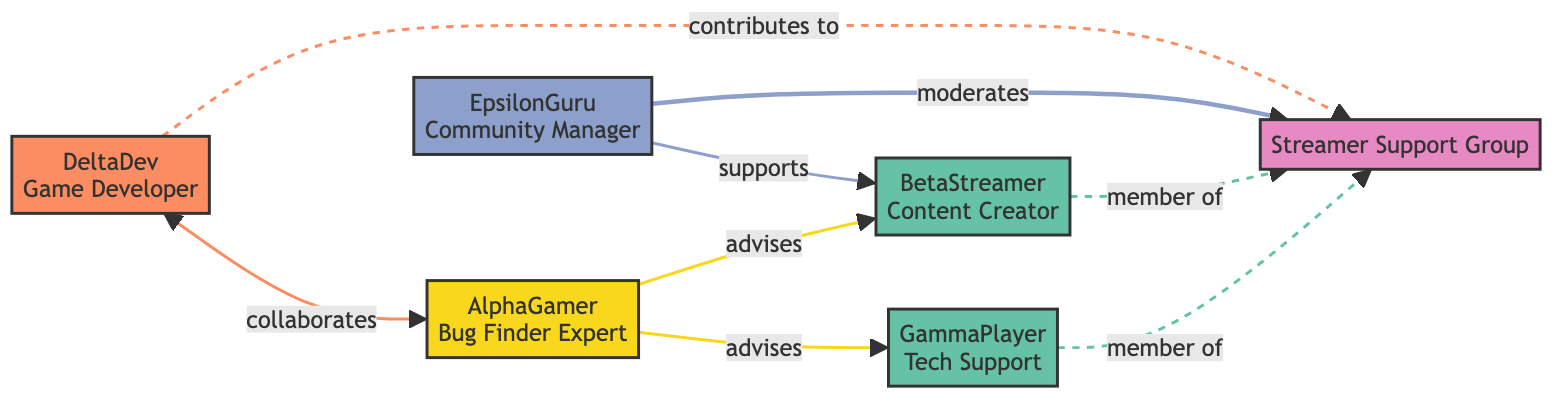What's the total number of nodes in the diagram? The diagram contains six distinct entities, which are represented as nodes. These nodes are alpha gamer, beta streamer, gamma player, delta dev, epsilon guru, and the support group. Thus, the total count is 6.
Answer: 6 Which streamer collaborates with DeltaDev? In the diagram, DeltaDev is shown to collaborate with AlphaGamer. The relationship is indicated by the connection labeled "collaborates." Thus, the answer is AlphaGamer.
Answer: AlphaGamer How many streamers are part of the support group? The diagram shows two members who are indicated to be part of the support group: BetaStreamer and GammaPlayer. Therefore, the count of streamers in the support group is 2.
Answer: 2 What type of relationship does EpsilonGuru have with BetaStreamer? The relationship between EpsilonGuru and BetaStreamer is labeled as "supports." This indicates that EpsilonGuru provides guidance and assistance to BetaStreamer. Hence, the answer is "supports."
Answer: supports Who moderates the Streamer Support Group? EpsilonGuru is explicitly mentioned in the diagram as the one who moderates the Streamer Support Group. This is corroborated by the connection labeled "moderates." Therefore, EpsilonGuru is the answer.
Answer: EpsilonGuru Does AlphaGamer advise GammaPlayer? Yes, AlphaGamer advises GammaPlayer, as indicated by the connection labeled "advises." This relationship confirms that AlphaGamer provides guidance to GammaPlayer regarding bug identification. Therefore, the answer is "yes."
Answer: yes What type of role does DeltaDev play in the group? DeltaDev contributes to the Streamer Support Group, as indicated in the diagram by the connection labeled "contributes to." This suggests that DeltaDev provides insights and adds value in the context of bug fixes. Therefore, the answer is "contributes to."
Answer: contributes to Which role does GammaPlayer hold? GammaPlayer's role is identified as "Tech Support Specialist." This is specified within the node representing GammaPlayer in the diagram. Thus, the answer is "Tech Support Specialist."
Answer: Tech Support Specialist 